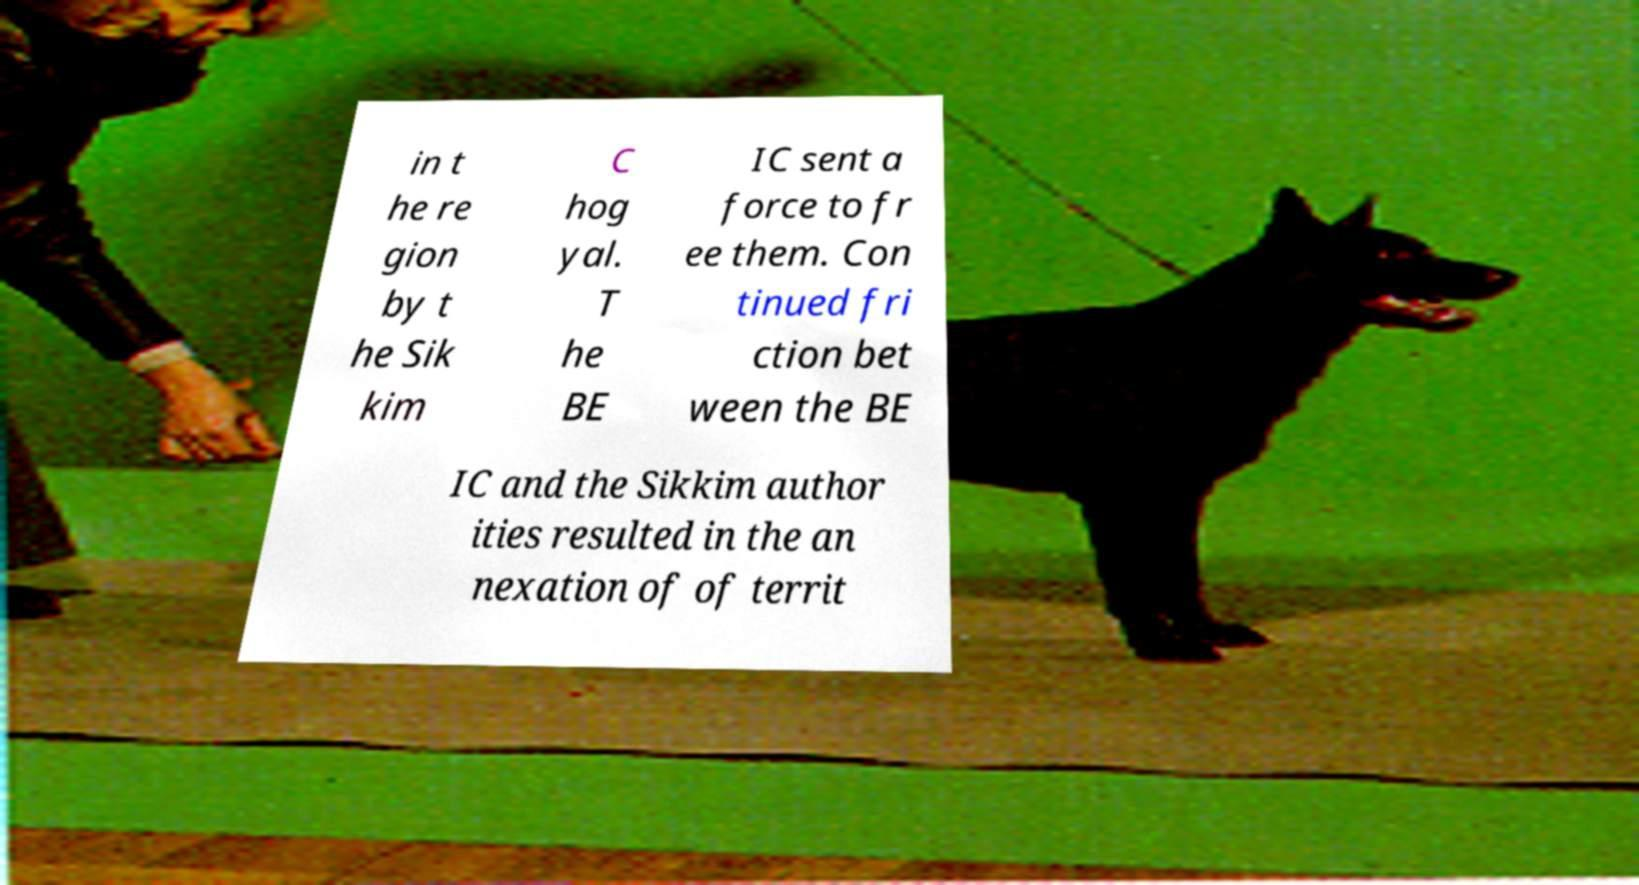I need the written content from this picture converted into text. Can you do that? in t he re gion by t he Sik kim C hog yal. T he BE IC sent a force to fr ee them. Con tinued fri ction bet ween the BE IC and the Sikkim author ities resulted in the an nexation of of territ 